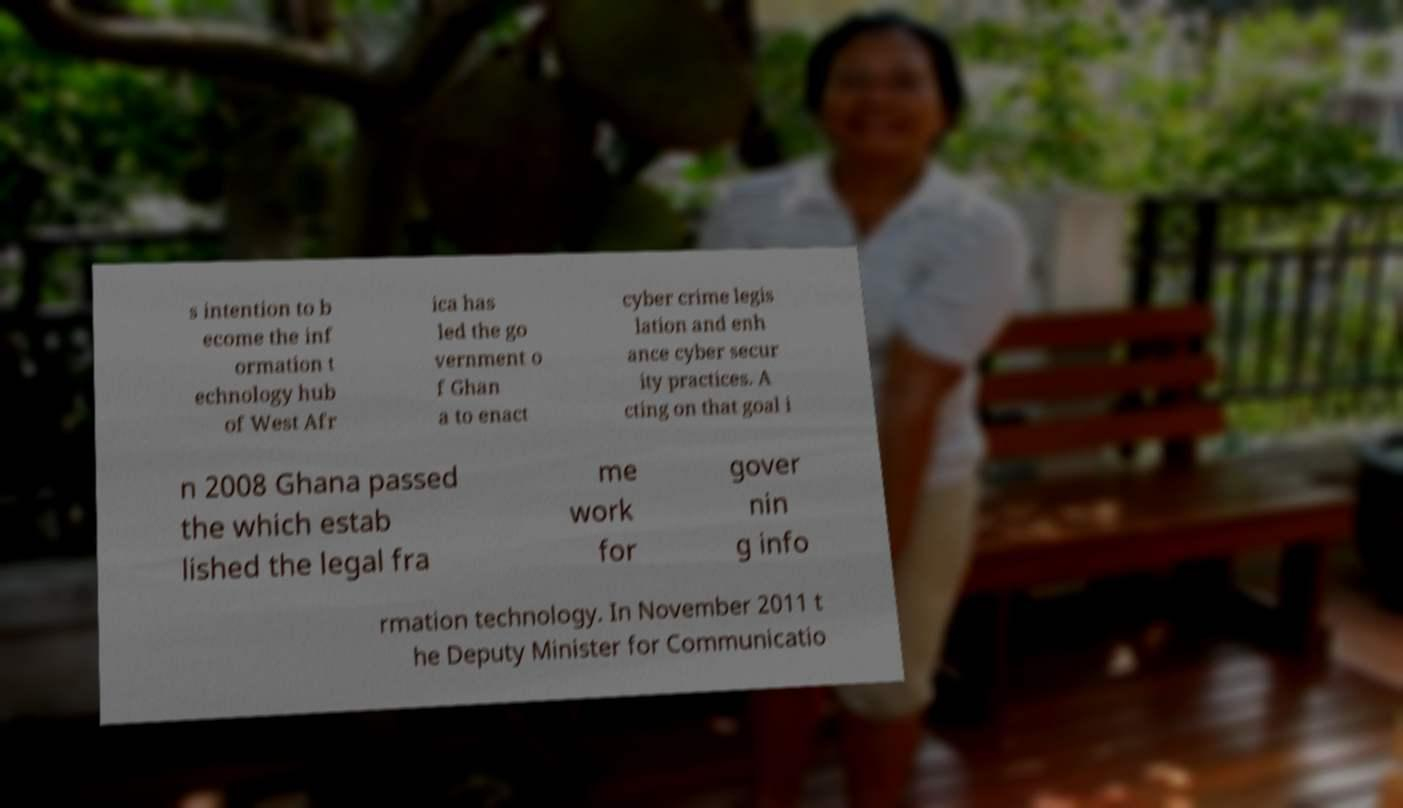Can you accurately transcribe the text from the provided image for me? s intention to b ecome the inf ormation t echnology hub of West Afr ica has led the go vernment o f Ghan a to enact cyber crime legis lation and enh ance cyber secur ity practices. A cting on that goal i n 2008 Ghana passed the which estab lished the legal fra me work for gover nin g info rmation technology. In November 2011 t he Deputy Minister for Communicatio 